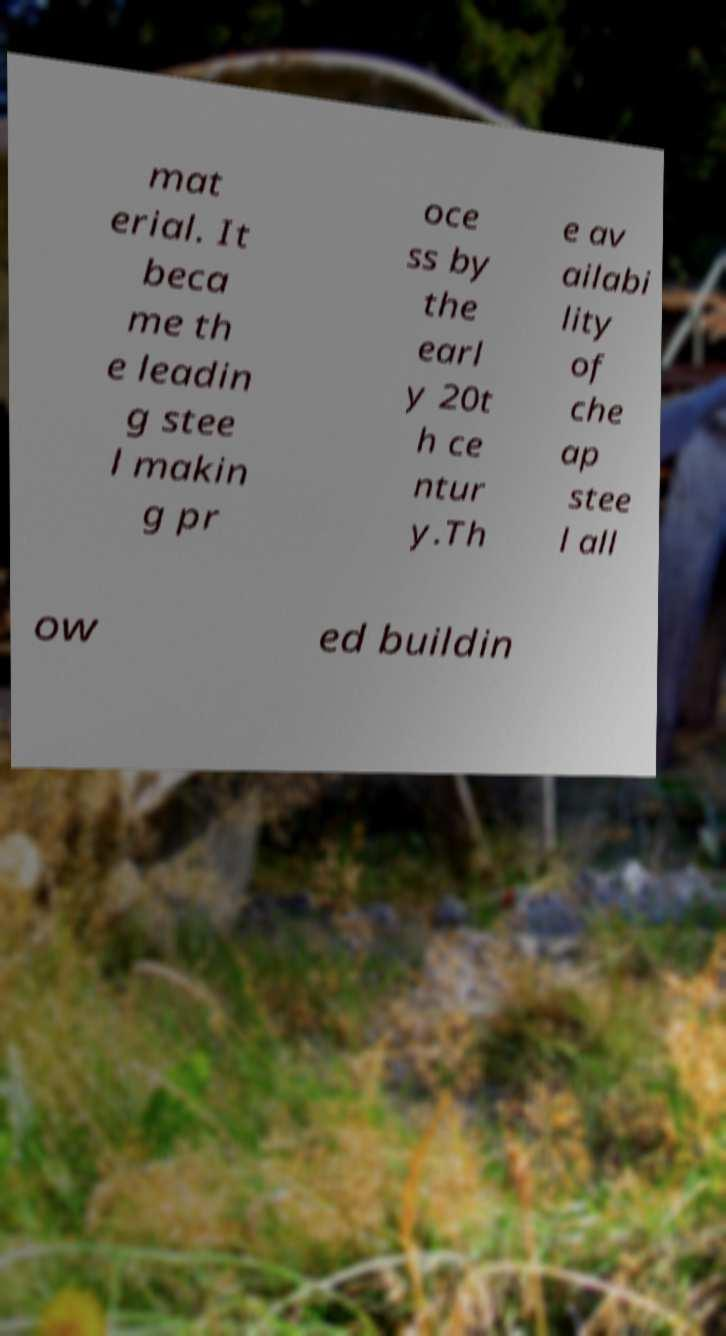For documentation purposes, I need the text within this image transcribed. Could you provide that? mat erial. It beca me th e leadin g stee l makin g pr oce ss by the earl y 20t h ce ntur y.Th e av ailabi lity of che ap stee l all ow ed buildin 